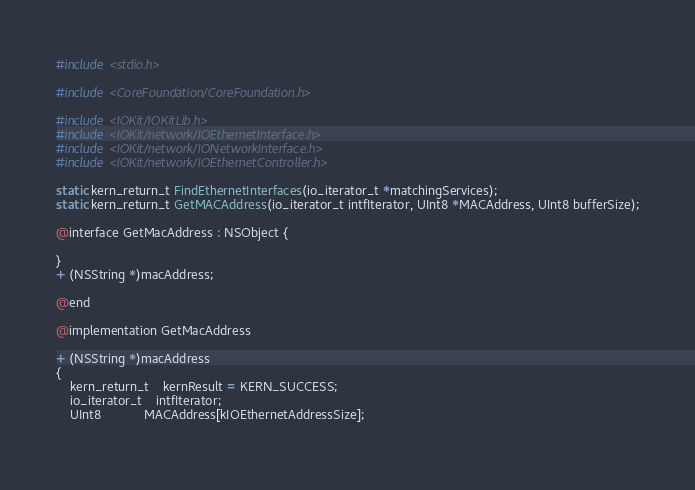<code> <loc_0><loc_0><loc_500><loc_500><_C_>#include <stdio.h>

#include <CoreFoundation/CoreFoundation.h>

#include <IOKit/IOKitLib.h>
#include <IOKit/network/IOEthernetInterface.h>
#include <IOKit/network/IONetworkInterface.h>
#include <IOKit/network/IOEthernetController.h>

static kern_return_t FindEthernetInterfaces(io_iterator_t *matchingServices);
static kern_return_t GetMACAddress(io_iterator_t intfIterator, UInt8 *MACAddress, UInt8 bufferSize);

@interface GetMacAddress : NSObject {

}
+ (NSString *)macAddress;

@end

@implementation GetMacAddress
	
+ (NSString *)macAddress
{
	kern_return_t	kernResult = KERN_SUCCESS;
    io_iterator_t	intfIterator;
    UInt8			MACAddress[kIOEthernetAddressSize];
	</code> 